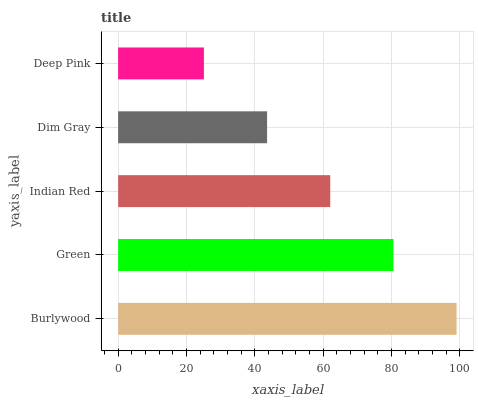Is Deep Pink the minimum?
Answer yes or no. Yes. Is Burlywood the maximum?
Answer yes or no. Yes. Is Green the minimum?
Answer yes or no. No. Is Green the maximum?
Answer yes or no. No. Is Burlywood greater than Green?
Answer yes or no. Yes. Is Green less than Burlywood?
Answer yes or no. Yes. Is Green greater than Burlywood?
Answer yes or no. No. Is Burlywood less than Green?
Answer yes or no. No. Is Indian Red the high median?
Answer yes or no. Yes. Is Indian Red the low median?
Answer yes or no. Yes. Is Green the high median?
Answer yes or no. No. Is Deep Pink the low median?
Answer yes or no. No. 